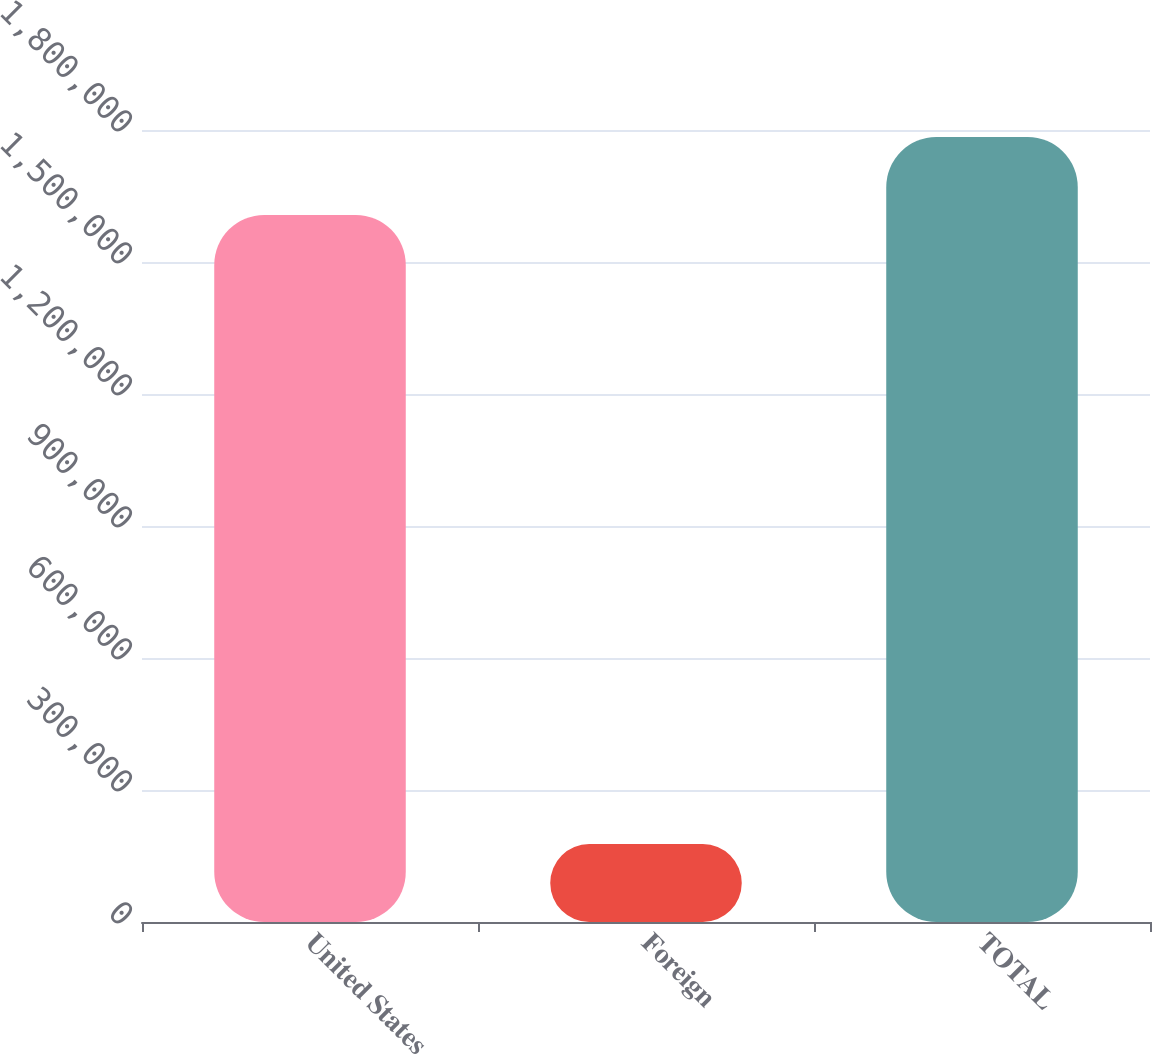Convert chart to OTSL. <chart><loc_0><loc_0><loc_500><loc_500><bar_chart><fcel>United States<fcel>Foreign<fcel>TOTAL<nl><fcel>1.60693e+06<fcel>177074<fcel>1.784e+06<nl></chart> 